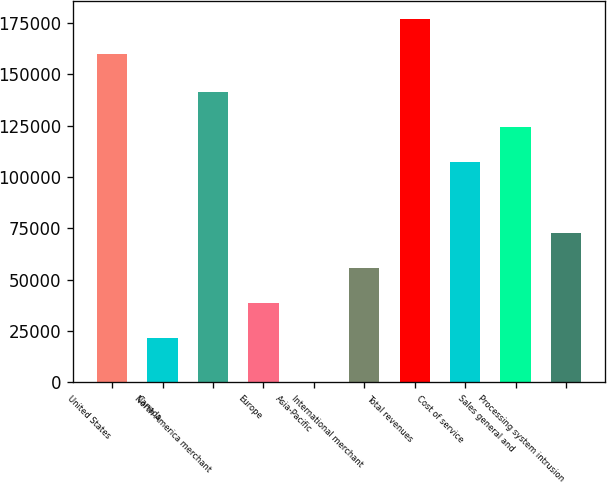Convert chart. <chart><loc_0><loc_0><loc_500><loc_500><bar_chart><fcel>United States<fcel>Canada<fcel>North America merchant<fcel>Europe<fcel>Asia-Pacific<fcel>International merchant<fcel>Total revenues<fcel>Cost of service<fcel>Sales general and<fcel>Processing system intrusion<nl><fcel>159857<fcel>21434<fcel>141635<fcel>38605.6<fcel>360<fcel>55777.2<fcel>177029<fcel>107292<fcel>124464<fcel>72948.8<nl></chart> 